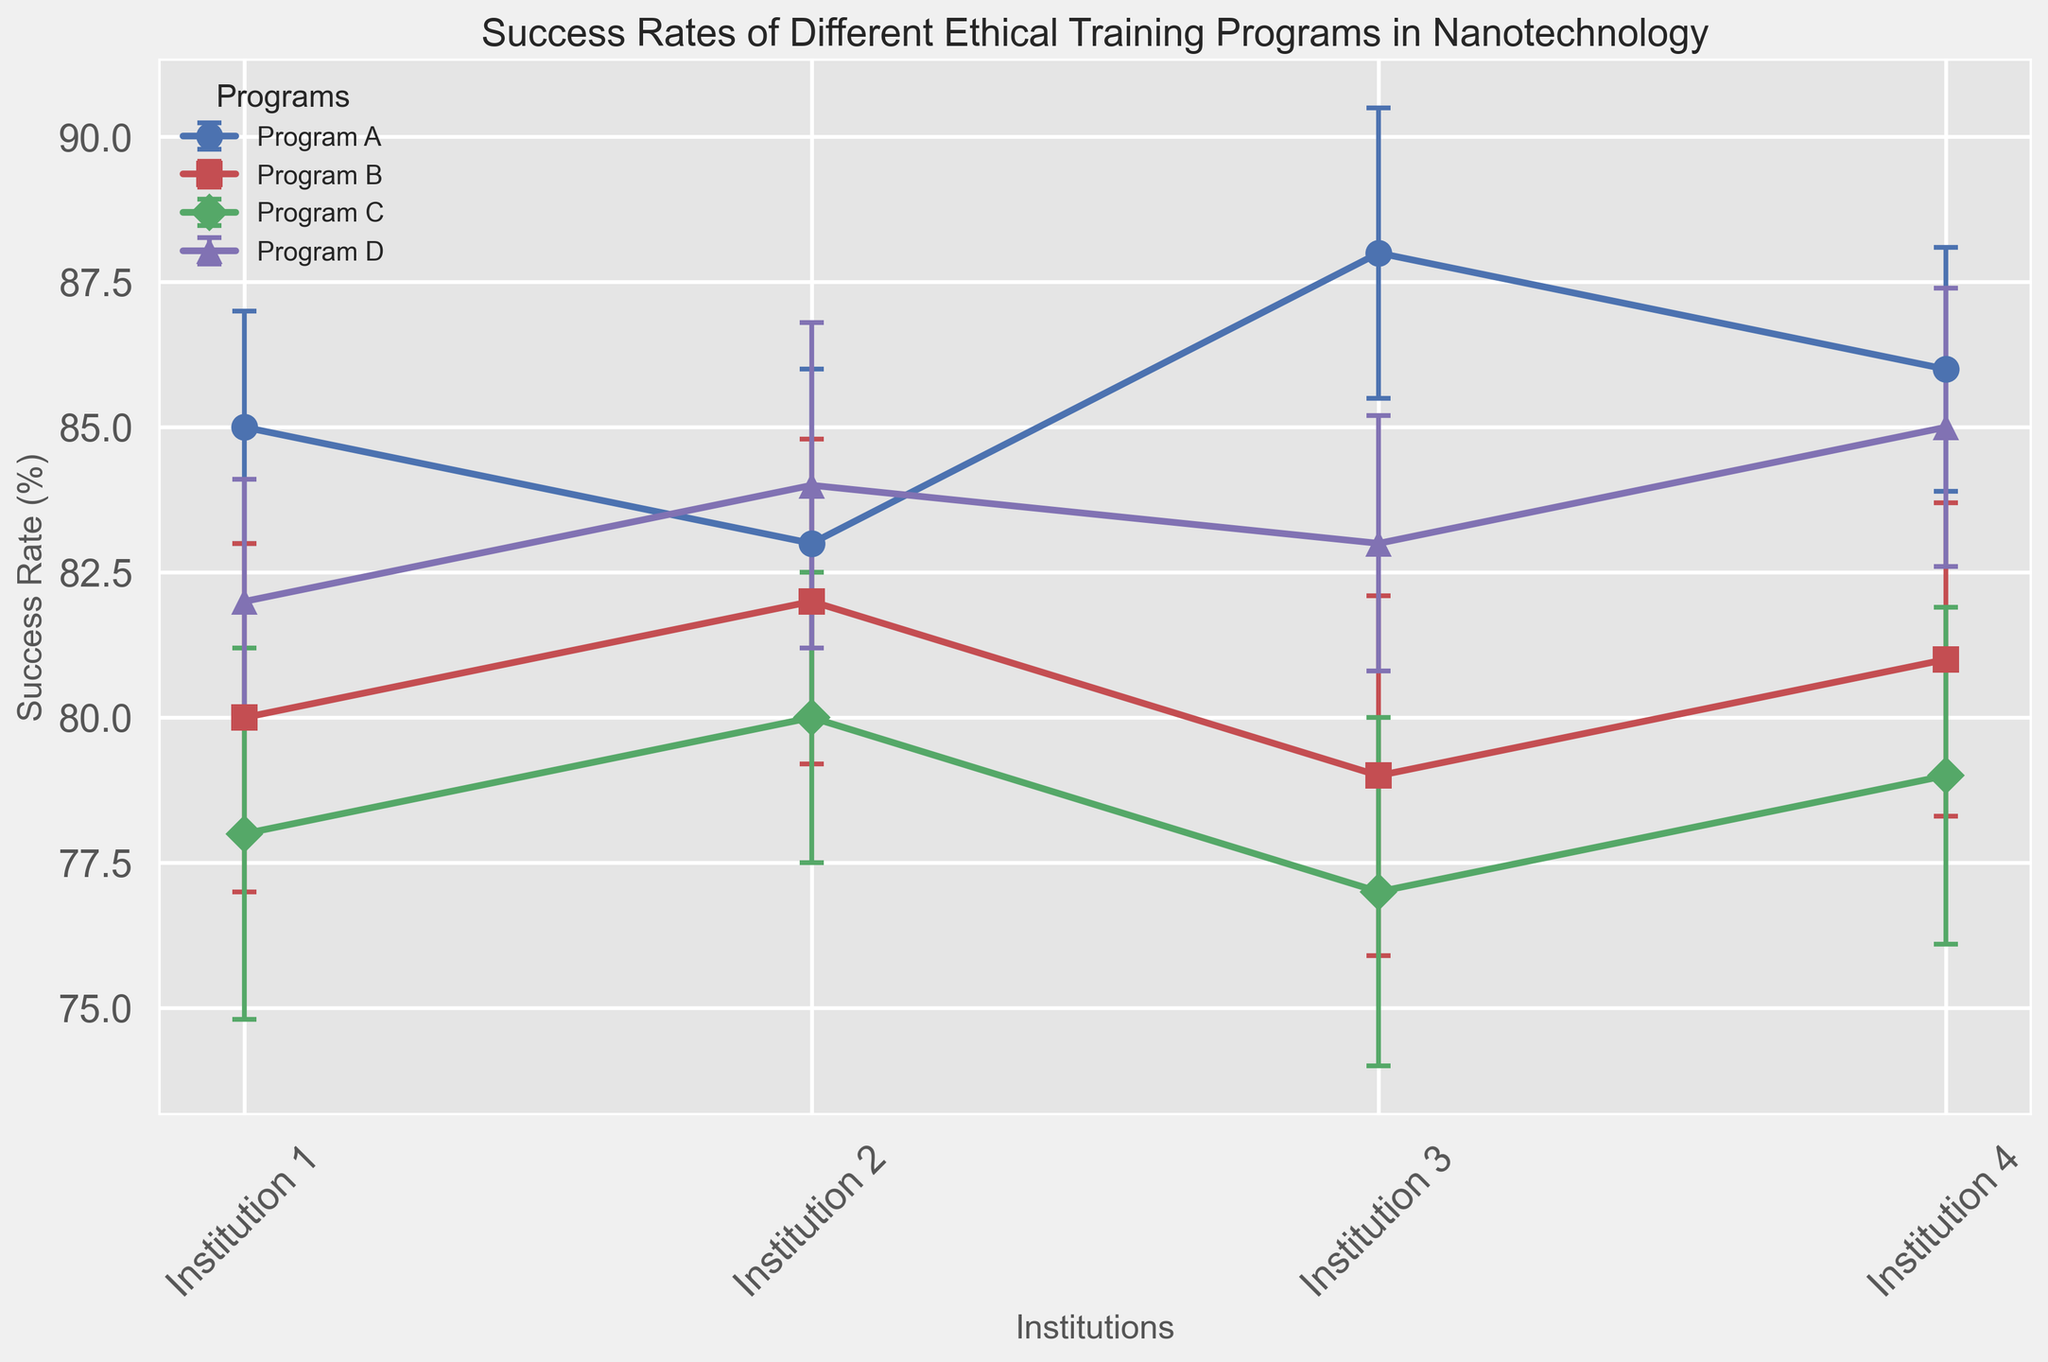What is the success rate of Program A at Institution 3? Looking at the figure, find the data point labeled Program A with the marker color and style for Institution 3.
Answer: 88% Which program had the highest success rate at Institution 1? Compare the success rates of all programs at Institution 1. The highest value belongs to Program A.
Answer: Program A How does the success rate of Program B at Institution 2 compare to Program D at Institution 2? Compare the success rate values shown for Institution 2 between Program B and Program D. Program D has a higher success rate.
Answer: Program D has a higher success rate What is the average success rate of Program C across all institutions? Add the success rates of Program C across all institutions and divide by the number of institutions (4). (78 + 80 + 77 + 79) / 4 = 78.5
Answer: 78.5 Which program shows the smallest variation in success rates across institutions? Observe the length of the error bars for each program across institutions. Program D has shorter error bars overall, indicating smaller variation.
Answer: Program D How much higher is the success rate of Program D at Institution 4 compared to Program C at the same institution? Subtract the success rate of Program C at Institution 4 from that of Program D at Institution 4. 85 - 79 = 6
Answer: 6 Which program has the largest error bar at any institution? Look for the longest error bar among all the programs; Program C at Institution 1 has the longest error bar of 3.2.
Answer: Program C What is the difference between the highest and the lowest success rate for Program B? Identify and subtract the lowest success rate (79) from the highest (82) from Program B's success rates. 82 - 79 = 3
Answer: 3 If we consider the error margins, which program shows the least overlap with others at any institution? Observe where error bars do not intersect with those of other programs, indicating less overlap. Program A at Institution 3 has minimal overlap with other programs.
Answer: Program A Are there any programs that have success rates within the same error margin at an institution? Check if the ranges defined by the success rate ± standard error overlap for any programs at an institution. Program B and Program D at Institution 1 have overlapping ranges (B: 77-83, D: 80-84).
Answer: Program B and Program D at Institution 1 